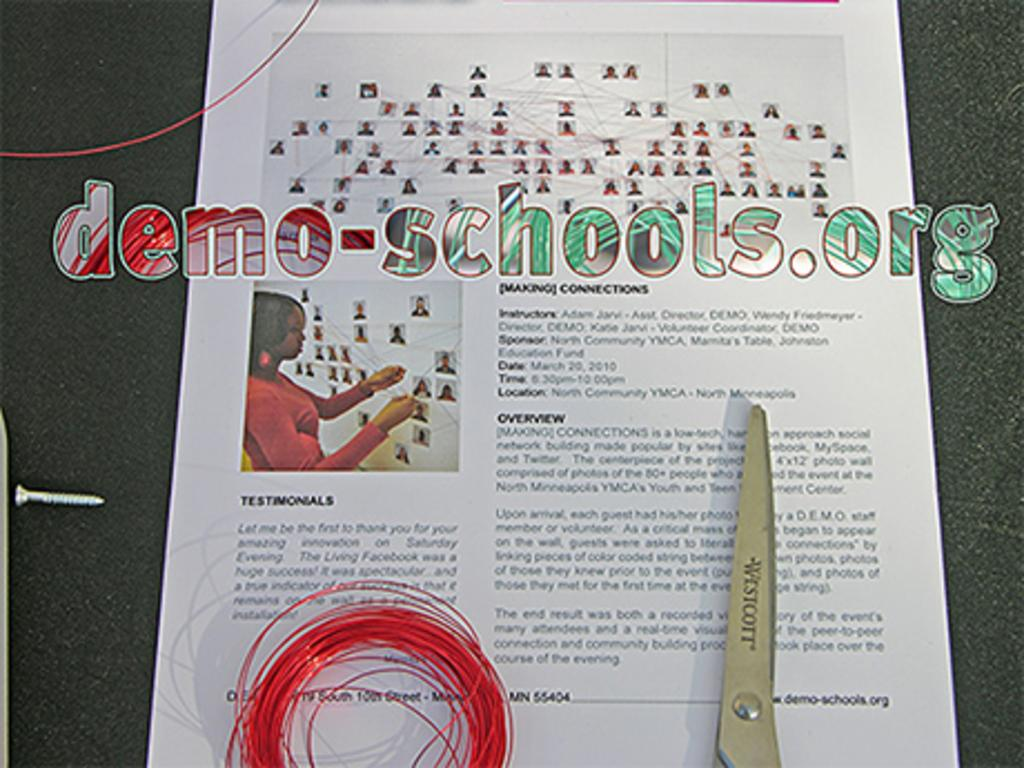What type of object can be seen in the image? There is a steel nail in the image. What else is present in the image? There is a thread, scissors, a paper, and a picture of a woman wearing clothes in the image. What is the purpose of the scissors in the image? The scissors are likely used for cutting the thread or paper. Can you describe the paper in the image? The paper has a watermark in the image. What type of tin can be seen bursting in the image? There is no tin or bursting action present in the image. What type of print is visible on the woman's clothes in the image? The image does not provide enough detail to determine if there is a print on the woman's clothes. 